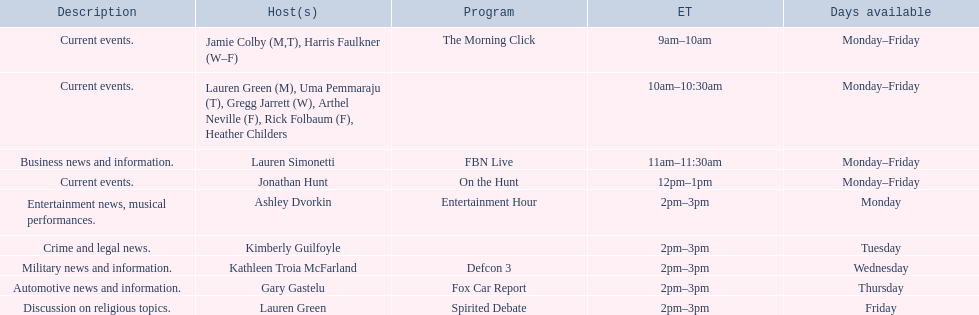How many days is fbn live available each week? 5. 